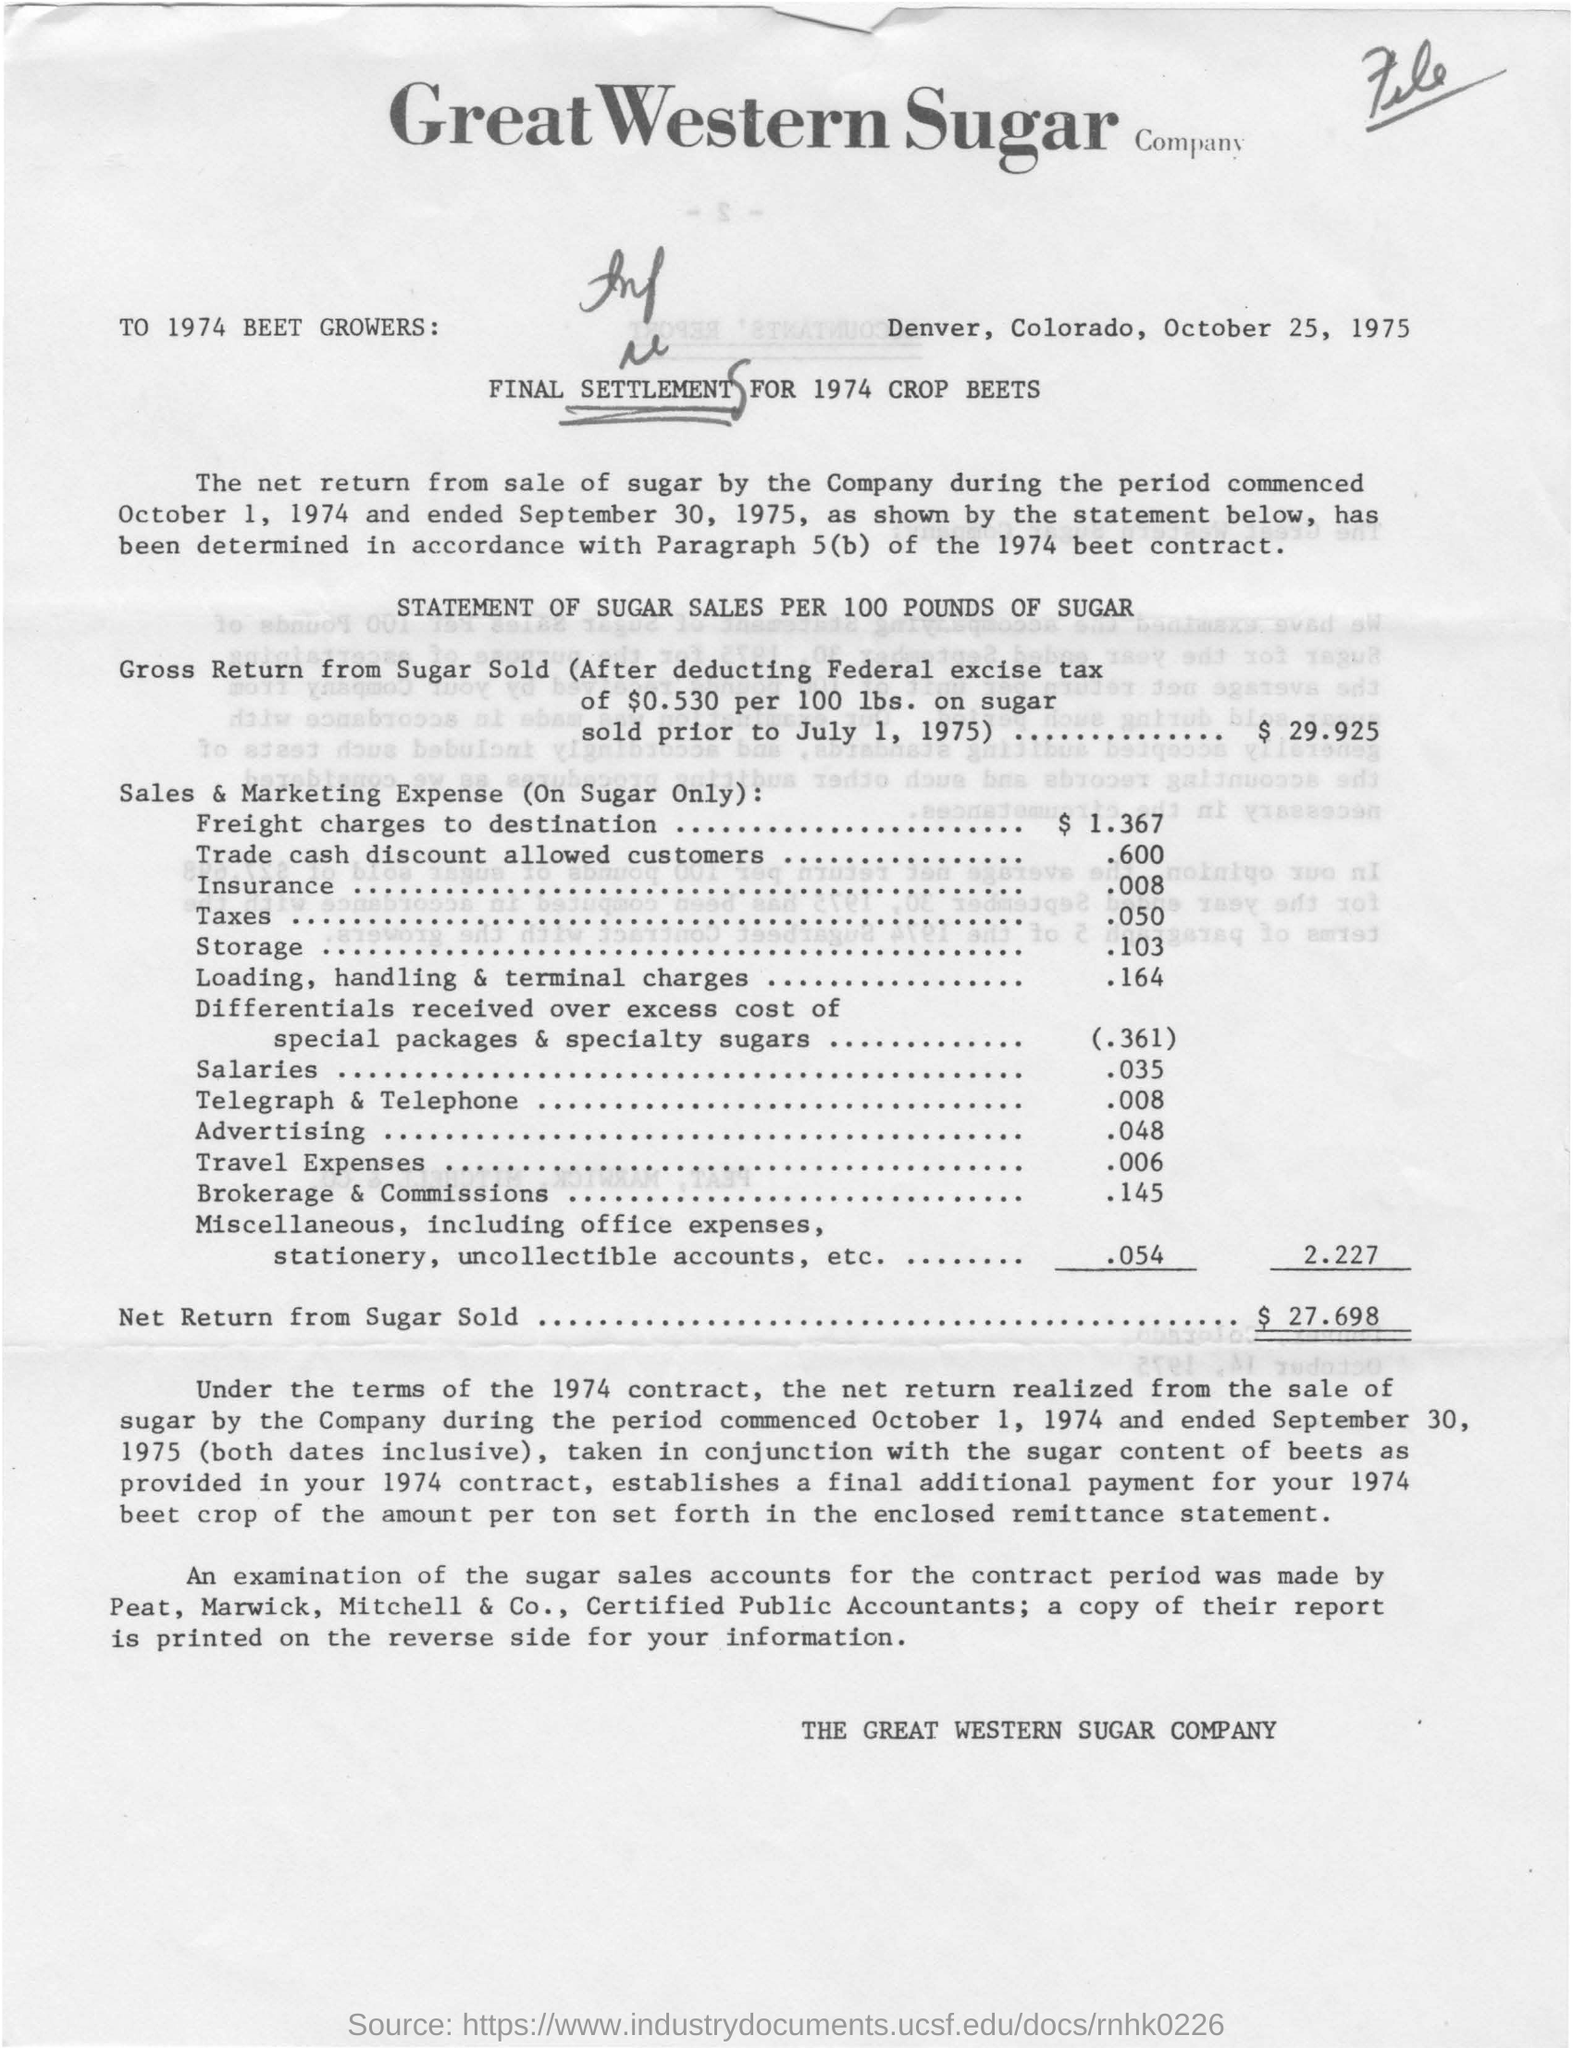List a handful of essential elements in this visual. The gross return from sugar sold is $29.925. The Great Western Sugar Company is mentioned. The document is dated October 25, 1975. 